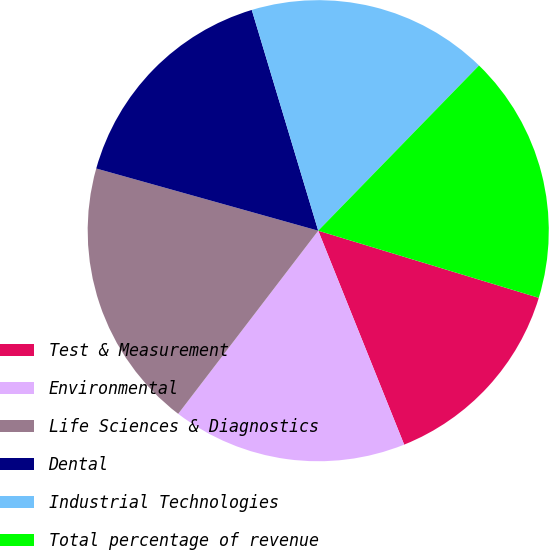Convert chart. <chart><loc_0><loc_0><loc_500><loc_500><pie_chart><fcel>Test & Measurement<fcel>Environmental<fcel>Life Sciences & Diagnostics<fcel>Dental<fcel>Industrial Technologies<fcel>Total percentage of revenue<nl><fcel>14.22%<fcel>16.47%<fcel>18.96%<fcel>16.0%<fcel>16.94%<fcel>17.42%<nl></chart> 